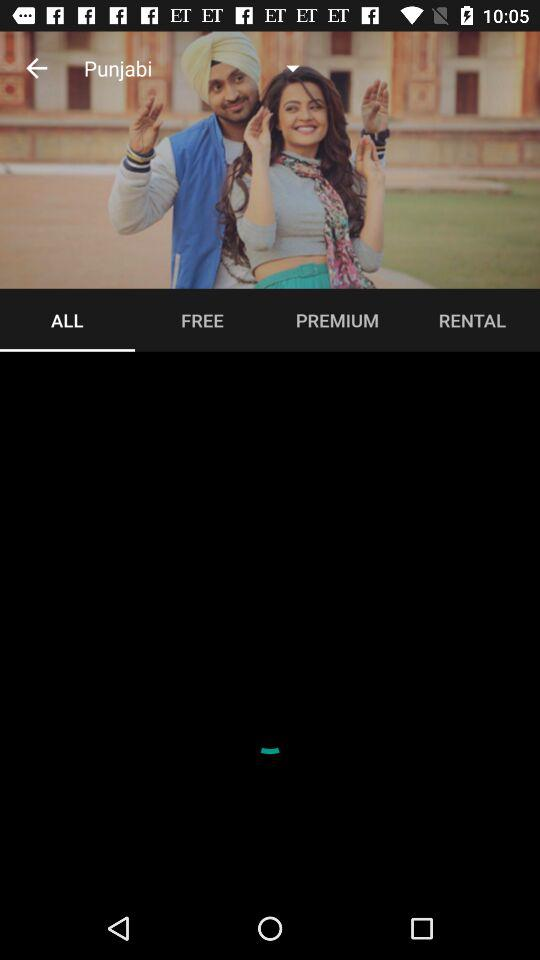Which tab is selected? The selected tab is "ALL". 